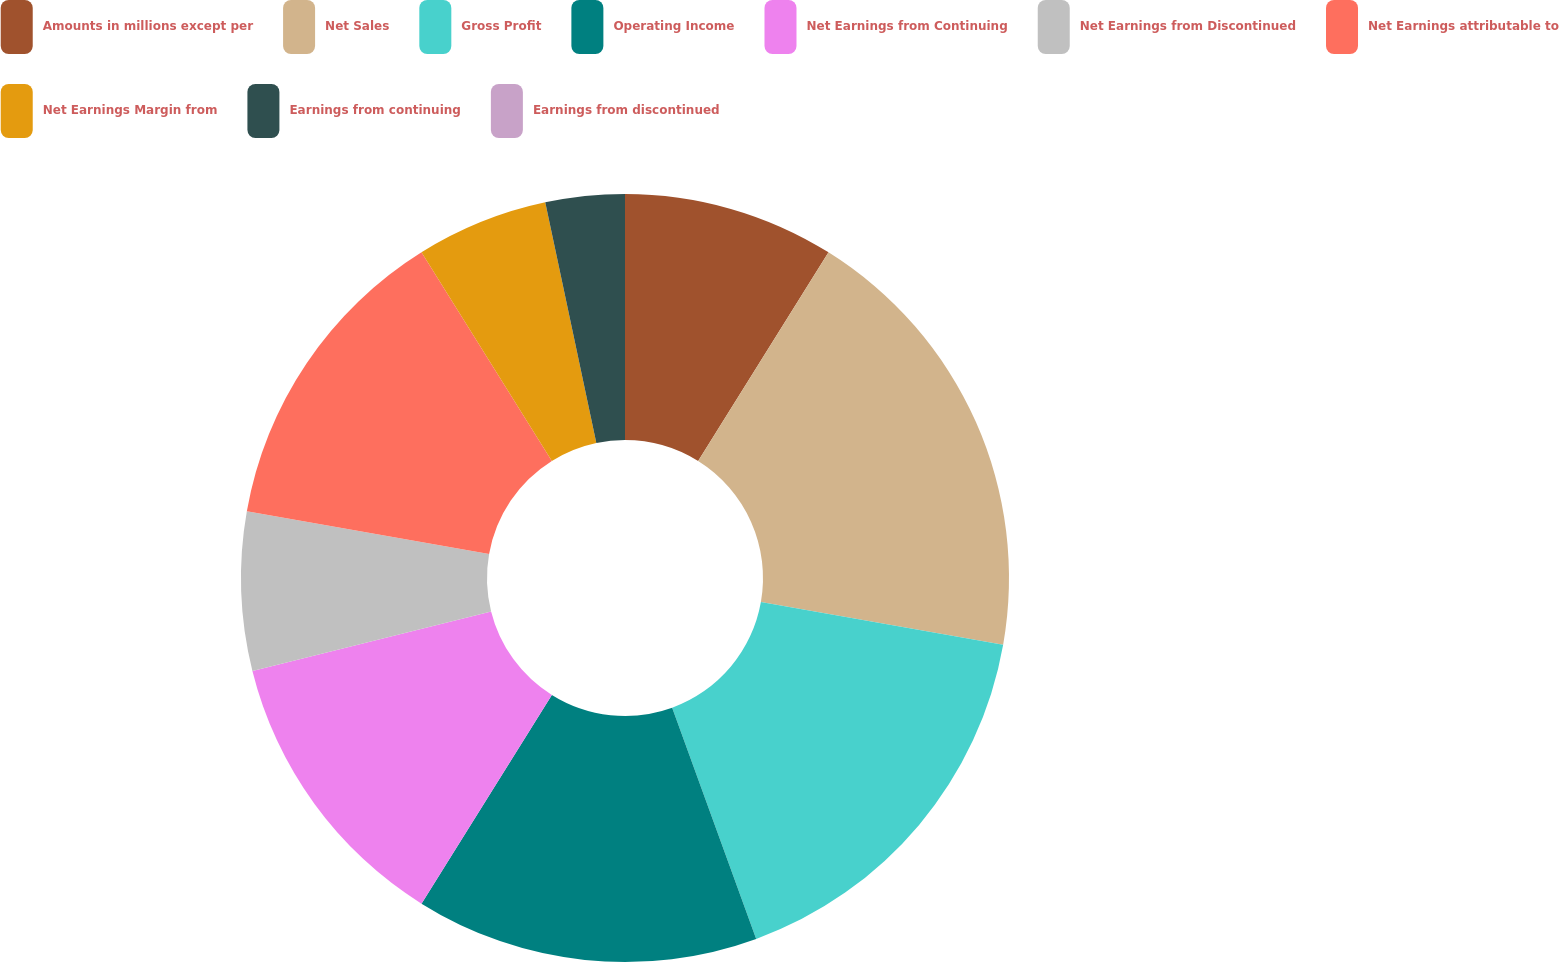<chart> <loc_0><loc_0><loc_500><loc_500><pie_chart><fcel>Amounts in millions except per<fcel>Net Sales<fcel>Gross Profit<fcel>Operating Income<fcel>Net Earnings from Continuing<fcel>Net Earnings from Discontinued<fcel>Net Earnings attributable to<fcel>Net Earnings Margin from<fcel>Earnings from continuing<fcel>Earnings from discontinued<nl><fcel>8.89%<fcel>18.89%<fcel>16.67%<fcel>14.44%<fcel>12.22%<fcel>6.67%<fcel>13.33%<fcel>5.56%<fcel>3.33%<fcel>0.0%<nl></chart> 